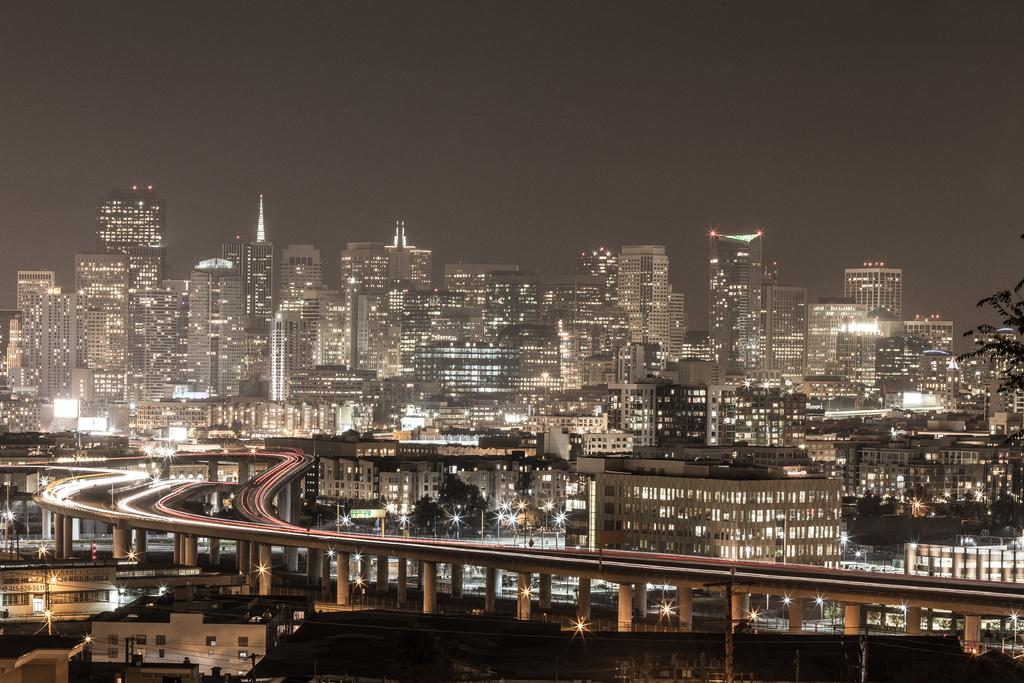What types of structures can be seen in the image? There are houses, buildings, pillars, bridges, and towers in the image. What architectural elements are present in the image? Pillars and towers are present in the image. What type of vegetation can be seen in the image? There are trees in the image. What type of lighting is visible in the image? There are lights and street lights in the image. What part of the natural environment is visible in the image? The sky is visible in the image. What time of day might the image have been taken? The image was likely taken during the night, as there are lights and street lights visible. What type of creature can be seen in the cemetery in the image? There is no cemetery present in the image, and therefore no such creature can be observed. What time of day is it in the image, considering the presence of morning light? The image was likely taken during the night, as there are lights and street lights visible, and there is no mention of morning light in the provided facts. 